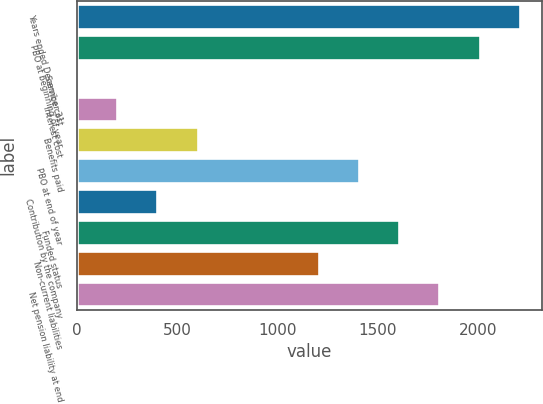Convert chart. <chart><loc_0><loc_0><loc_500><loc_500><bar_chart><fcel>Years ended December 31<fcel>PBO at beginning of year<fcel>Service cost<fcel>Interest cost<fcel>Benefits paid<fcel>PBO at end of year<fcel>Contribution by the company<fcel>Funded status<fcel>Non-current liabilities<fcel>Net pension liability at end<nl><fcel>2210.98<fcel>2010<fcel>0.2<fcel>201.18<fcel>603.14<fcel>1407.06<fcel>402.16<fcel>1608.04<fcel>1206.08<fcel>1809.02<nl></chart> 